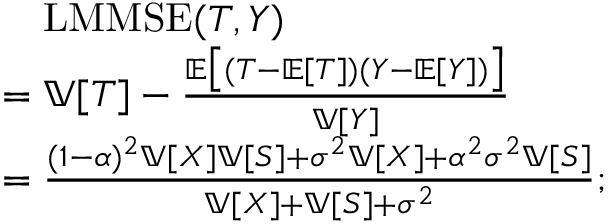Convert formula to latex. <formula><loc_0><loc_0><loc_500><loc_500>\begin{array} { r l } & { \quad L M M S E ( T , Y ) } \\ & { = \mathbb { V } [ T ] - \frac { \mathbb { E } \left [ ( T - \mathbb { E } [ T ] ) ( Y - \mathbb { E } [ Y ] ) \right ] } { \mathbb { V } [ Y ] } } \\ & { = \frac { ( 1 - \alpha ) ^ { 2 } \mathbb { V } [ X ] \mathbb { V } [ S ] + \sigma ^ { 2 } \mathbb { V } [ X ] + \alpha ^ { 2 } \sigma ^ { 2 } \mathbb { V } [ S ] } { \mathbb { V } [ X ] + \mathbb { V } [ S ] + \sigma ^ { 2 } } ; } \end{array}</formula> 